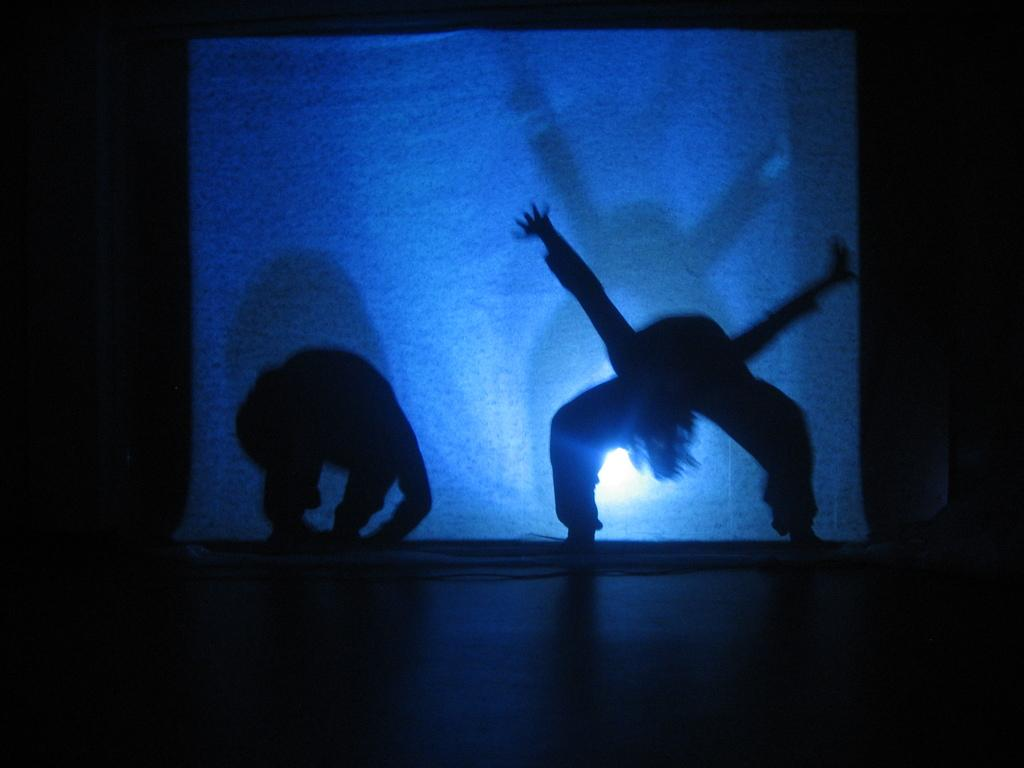How many people are in the image? There are two persons in the image. What are the two persons doing in the image? The two persons appear to be dancing. What can be seen in the background of the image? There is a white screen in the background of the image. What type of tin can be seen on the floor during the dance routine? There is no tin present on the floor during the dance routine in the image. 